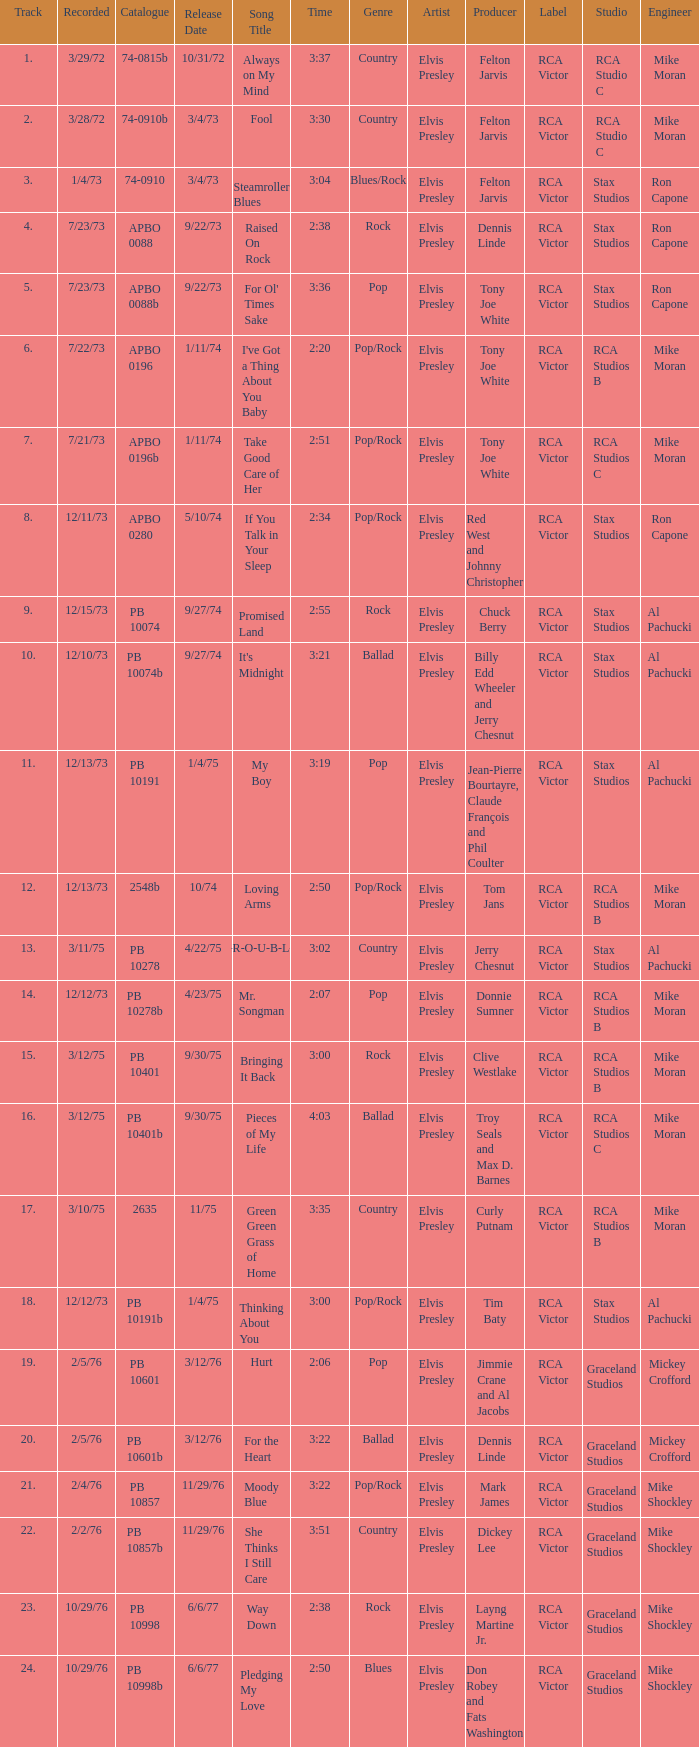Tell me the recorded for time of 2:50 and released date of 6/6/77 with track more than 20 10/29/76. 